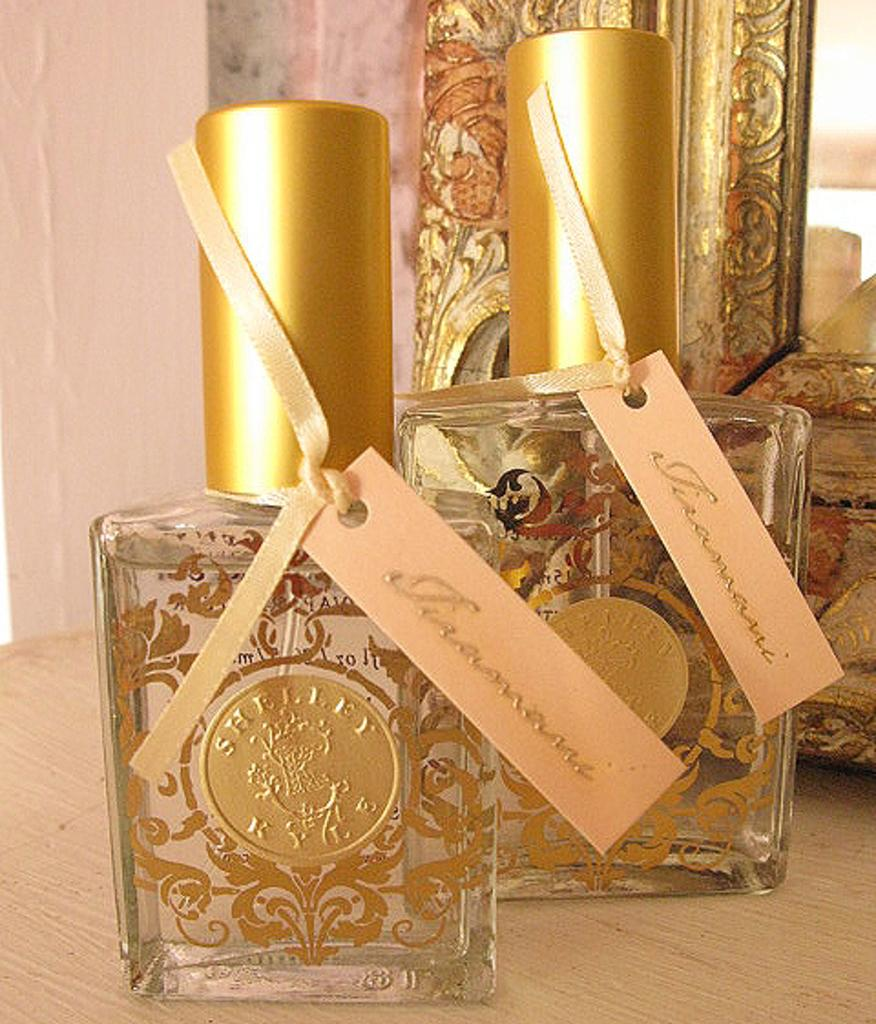What type of objects can be seen in the image? There are perfume bottles in the image. What else is present in the image besides the perfume bottles? There is a frame in the image. Can you describe the frame's location? The frame is on a wooden object. What can be seen in the background of the image? There is a wall in the background of the image. What type of creature is holding the perfume bottles in the image? There is no creature present in the image; the perfume bottles are simply placed on a surface. 